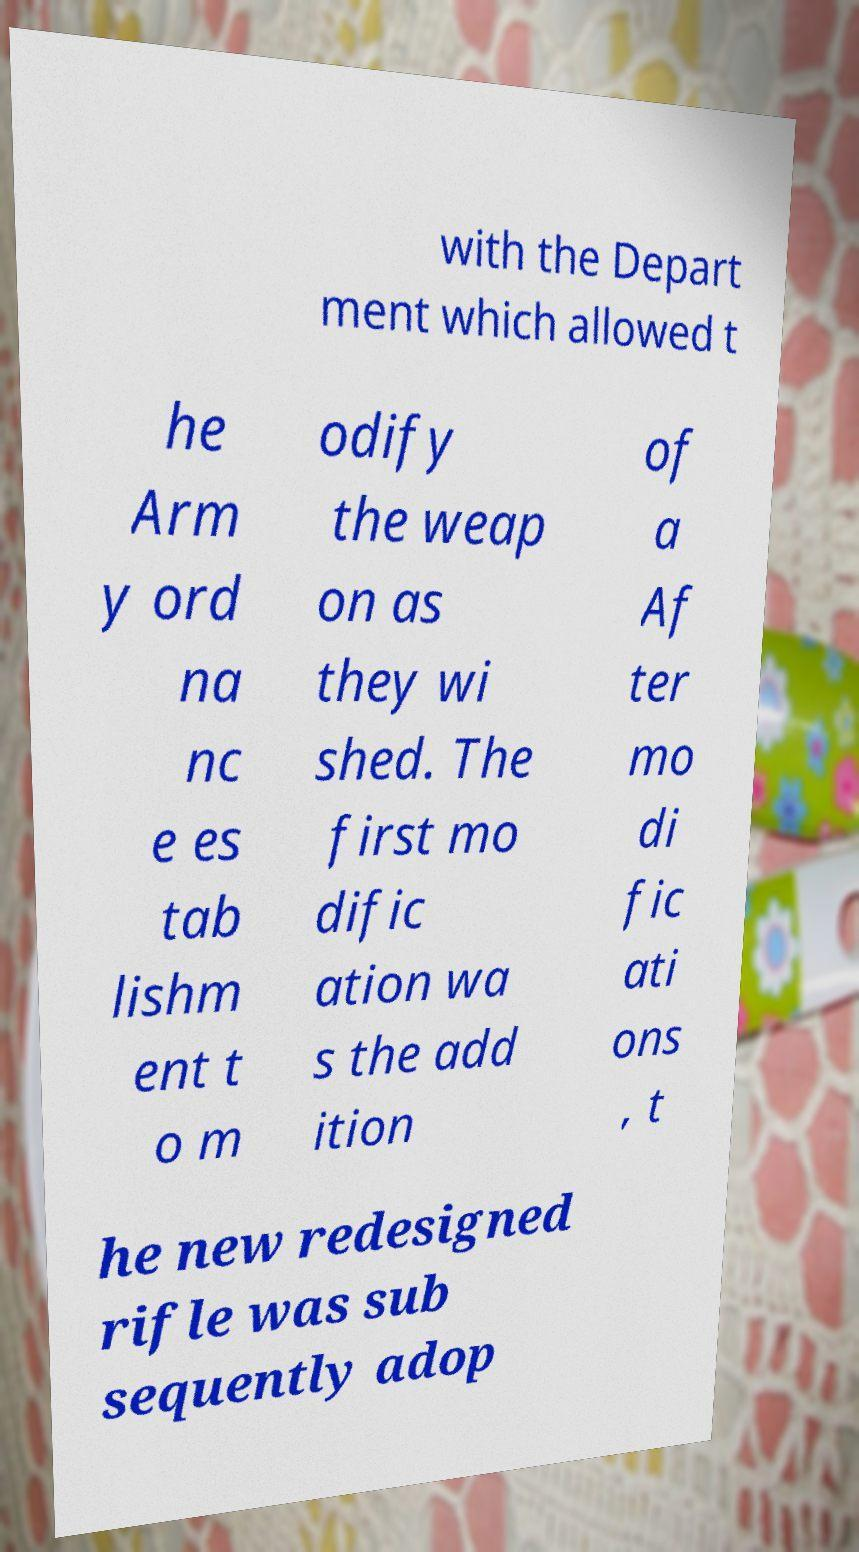Could you assist in decoding the text presented in this image and type it out clearly? with the Depart ment which allowed t he Arm y ord na nc e es tab lishm ent t o m odify the weap on as they wi shed. The first mo dific ation wa s the add ition of a Af ter mo di fic ati ons , t he new redesigned rifle was sub sequently adop 